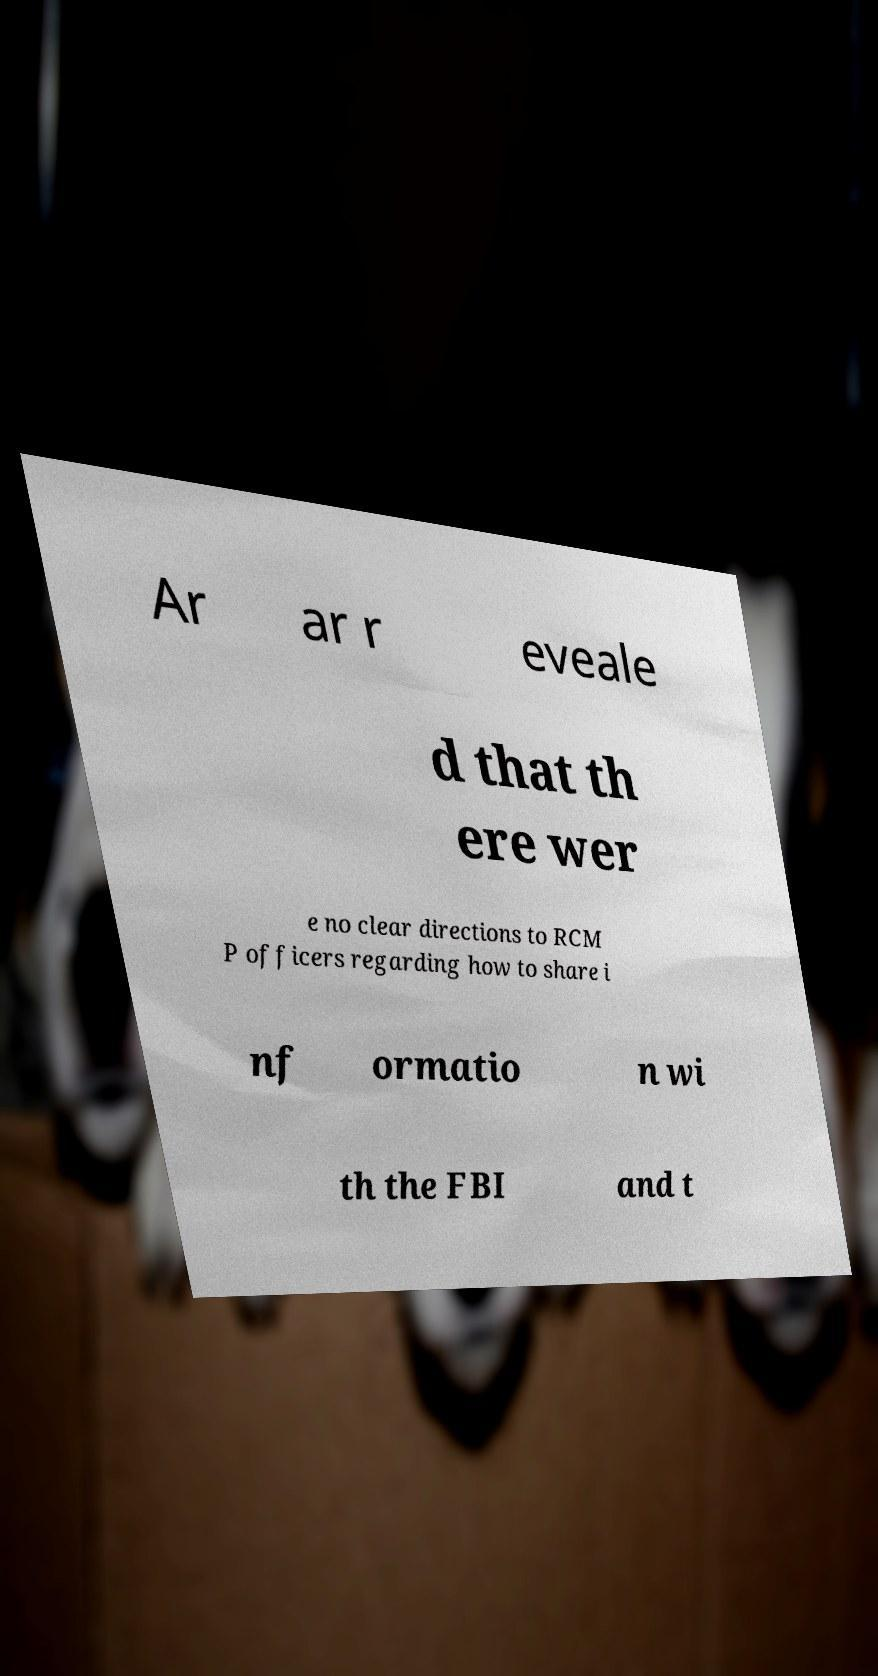Could you extract and type out the text from this image? Ar ar r eveale d that th ere wer e no clear directions to RCM P officers regarding how to share i nf ormatio n wi th the FBI and t 